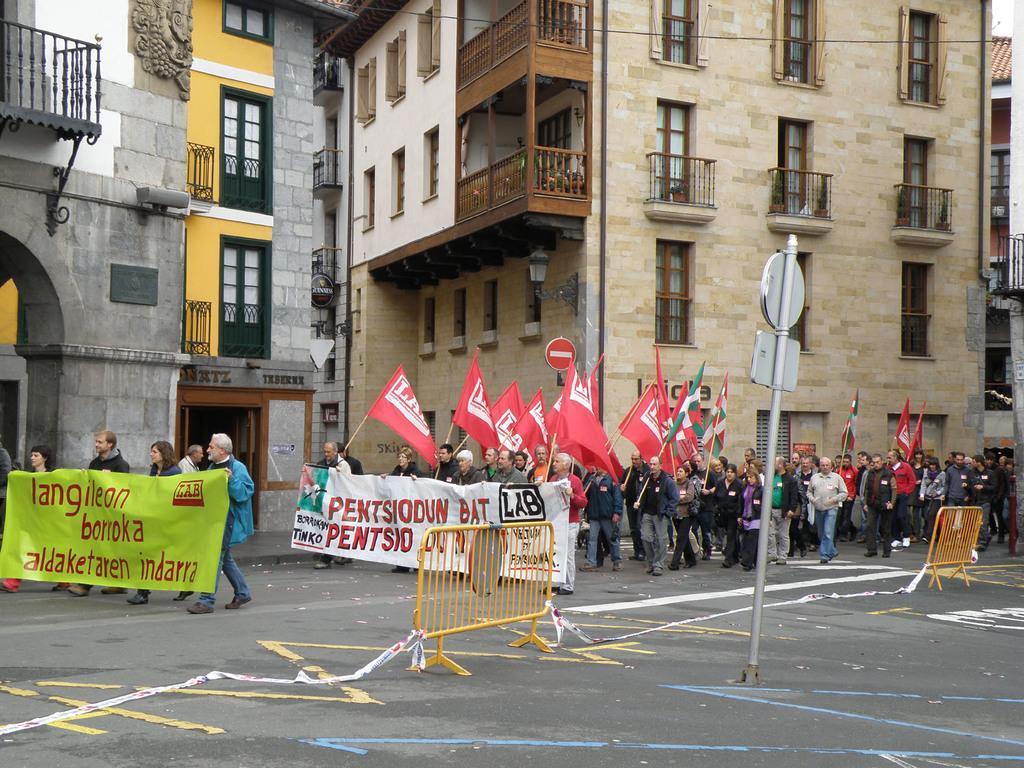Describe this image in one or two sentences. In this picture there is a group of men and women walking on the street holding red color flags in the hand. In the front there is a yellow color fencing grill placed on the road. In the background there is a brown color building with glass windows. 